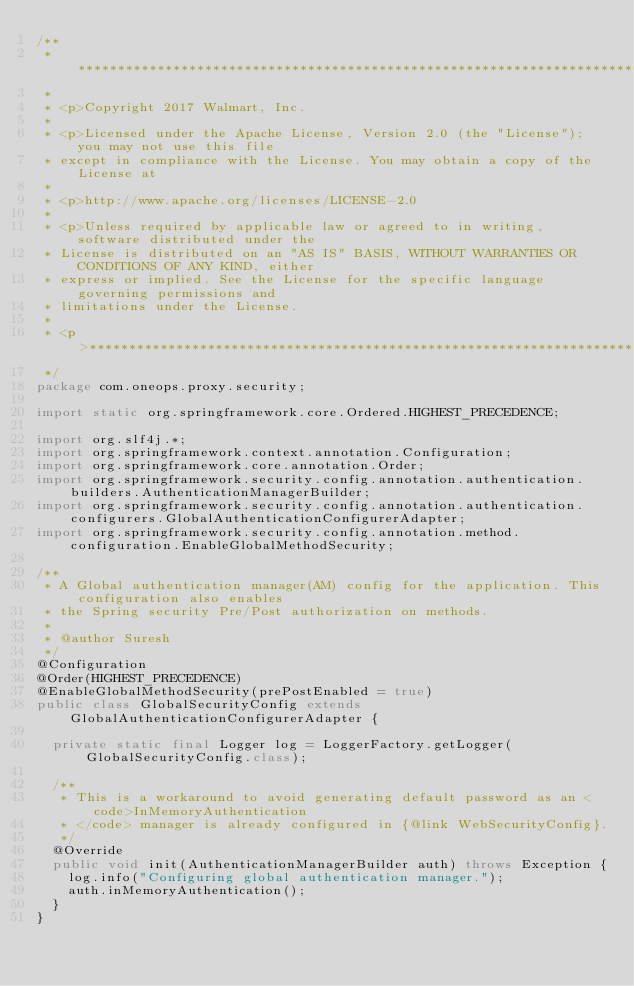<code> <loc_0><loc_0><loc_500><loc_500><_Java_>/**
 * *****************************************************************************
 *
 * <p>Copyright 2017 Walmart, Inc.
 *
 * <p>Licensed under the Apache License, Version 2.0 (the "License"); you may not use this file
 * except in compliance with the License. You may obtain a copy of the License at
 *
 * <p>http://www.apache.org/licenses/LICENSE-2.0
 *
 * <p>Unless required by applicable law or agreed to in writing, software distributed under the
 * License is distributed on an "AS IS" BASIS, WITHOUT WARRANTIES OR CONDITIONS OF ANY KIND, either
 * express or implied. See the License for the specific language governing permissions and
 * limitations under the License.
 *
 * <p>*****************************************************************************
 */
package com.oneops.proxy.security;

import static org.springframework.core.Ordered.HIGHEST_PRECEDENCE;

import org.slf4j.*;
import org.springframework.context.annotation.Configuration;
import org.springframework.core.annotation.Order;
import org.springframework.security.config.annotation.authentication.builders.AuthenticationManagerBuilder;
import org.springframework.security.config.annotation.authentication.configurers.GlobalAuthenticationConfigurerAdapter;
import org.springframework.security.config.annotation.method.configuration.EnableGlobalMethodSecurity;

/**
 * A Global authentication manager(AM) config for the application. This configuration also enables
 * the Spring security Pre/Post authorization on methods.
 *
 * @author Suresh
 */
@Configuration
@Order(HIGHEST_PRECEDENCE)
@EnableGlobalMethodSecurity(prePostEnabled = true)
public class GlobalSecurityConfig extends GlobalAuthenticationConfigurerAdapter {

  private static final Logger log = LoggerFactory.getLogger(GlobalSecurityConfig.class);

  /**
   * This is a workaround to avoid generating default password as an <code>InMemoryAuthentication
   * </code> manager is already configured in {@link WebSecurityConfig}.
   */
  @Override
  public void init(AuthenticationManagerBuilder auth) throws Exception {
    log.info("Configuring global authentication manager.");
    auth.inMemoryAuthentication();
  }
}
</code> 